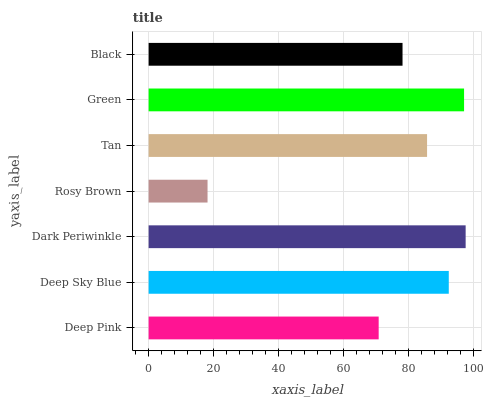Is Rosy Brown the minimum?
Answer yes or no. Yes. Is Dark Periwinkle the maximum?
Answer yes or no. Yes. Is Deep Sky Blue the minimum?
Answer yes or no. No. Is Deep Sky Blue the maximum?
Answer yes or no. No. Is Deep Sky Blue greater than Deep Pink?
Answer yes or no. Yes. Is Deep Pink less than Deep Sky Blue?
Answer yes or no. Yes. Is Deep Pink greater than Deep Sky Blue?
Answer yes or no. No. Is Deep Sky Blue less than Deep Pink?
Answer yes or no. No. Is Tan the high median?
Answer yes or no. Yes. Is Tan the low median?
Answer yes or no. Yes. Is Dark Periwinkle the high median?
Answer yes or no. No. Is Rosy Brown the low median?
Answer yes or no. No. 